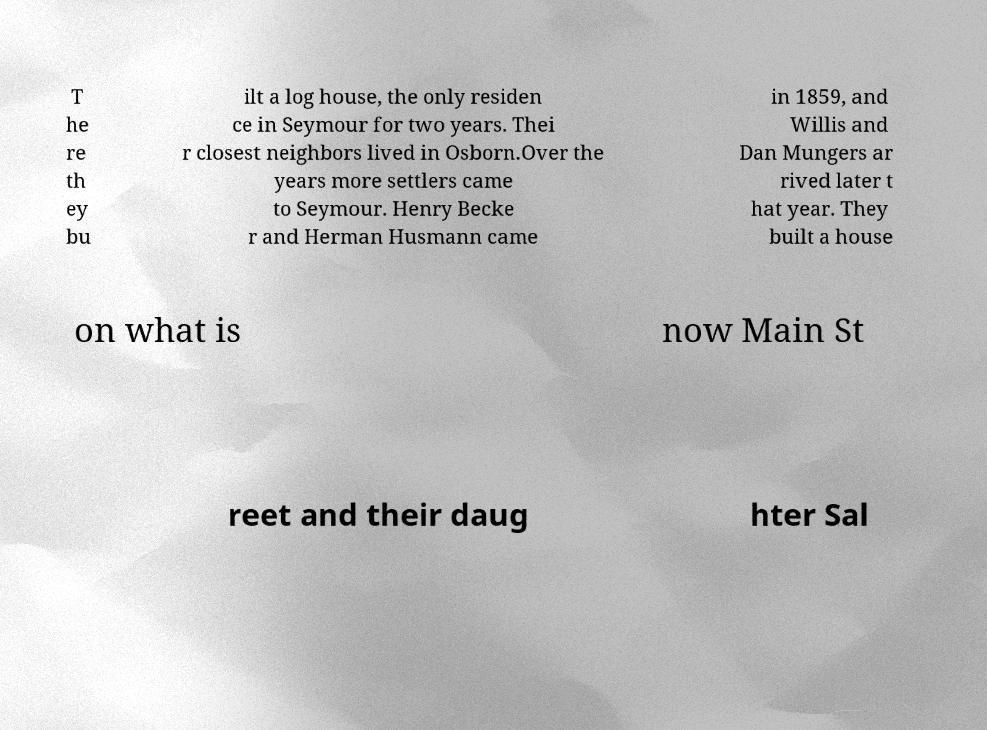Could you extract and type out the text from this image? T he re th ey bu ilt a log house, the only residen ce in Seymour for two years. Thei r closest neighbors lived in Osborn.Over the years more settlers came to Seymour. Henry Becke r and Herman Husmann came in 1859, and Willis and Dan Mungers ar rived later t hat year. They built a house on what is now Main St reet and their daug hter Sal 